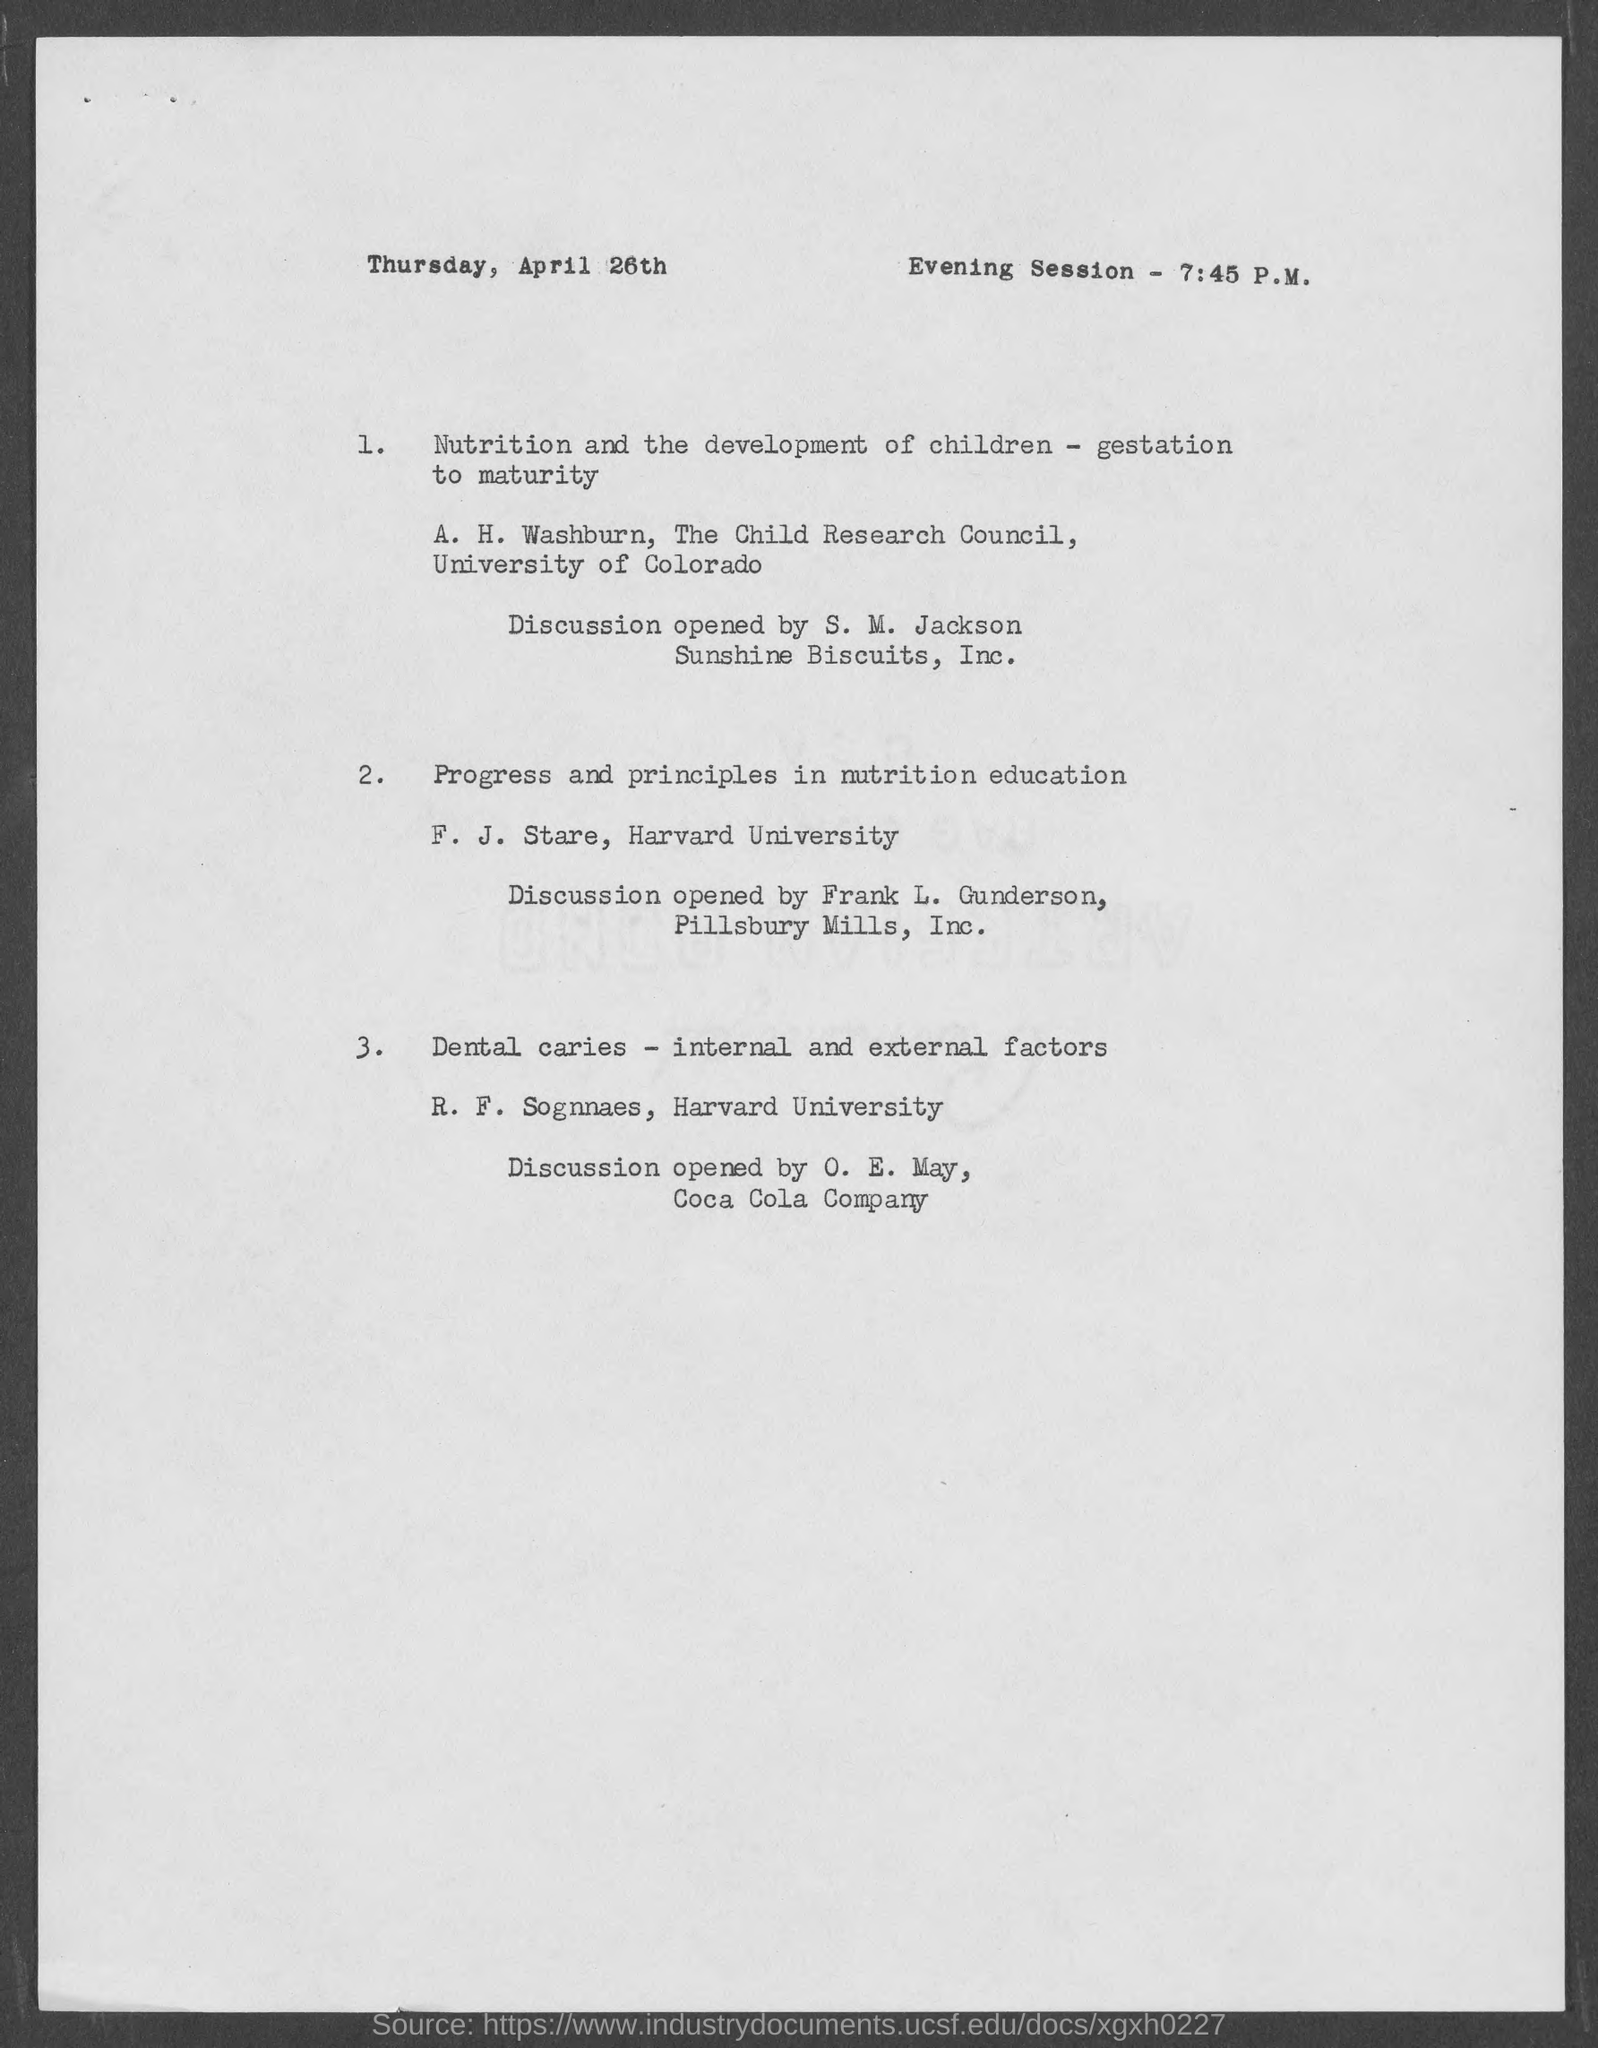When will the evening session will start ?
Offer a very short reply. 7:45 P.M. What is the date,day and month shown in the document?
Offer a very short reply. Thursday, April 26th. In which university, does " A. H. Washburn" works?
Offer a very short reply. University of Colorado. In which univeristy, does " F. J. Stare" works?
Your response must be concise. Harvard university. In which university, does " R. F.Sognnaes" works?
Your answer should be compact. Harvard University. Who conduct the discussion of the paper " Nutrition and the development of children - gestation to maturity " ?
Give a very brief answer. A. H. Washburn. Who conduct the discussion of the paper "Progress and principles in nutrition education" ?
Provide a short and direct response. F. J. Stare. In which combany, does "O. E. May" works?
Provide a short and direct response. Coca Cola Company. Which council does " A. H. Washburn " works ?
Your answer should be compact. The Child Research Council. 